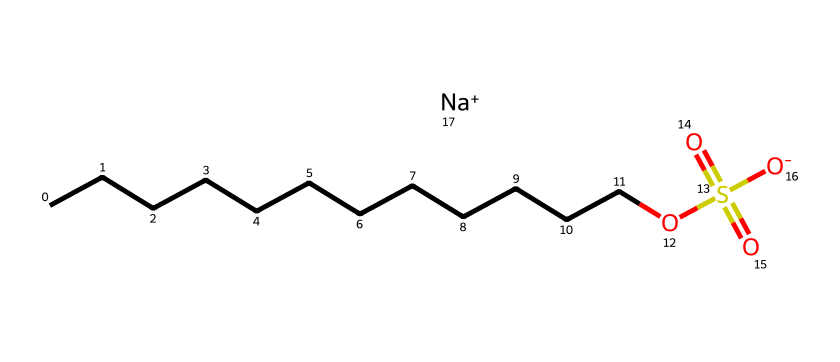What is the total number of carbon atoms in sodium dodecyl sulfate? The SMILES representation shows a straight chain of carbon atoms denoted by the "CCCCCCCCCCCC" part, which indicates there are 12 carbon atoms connected in a linear chain.
Answer: 12 How many oxygen atoms are in the structure of sodium dodecyl sulfate? In the SMILES, there are two oxygen atoms in the sulfate group "OS(=O)(=O)" and one additional oxygen in the hydroxyl part -O, resulting in a total of three oxygen atoms.
Answer: 3 What type of ion does sodium dodecyl sulfate contain? The "Na+" part of the SMILES indicates the presence of a sodium ion, which is a positively charged ion (cation) associated with the surfactant.
Answer: sodium ion What feature of sodium dodecyl sulfate contributes to its surfactant properties? The presence of a long hydrophobic carbon chain (the "CCCCCCCCCCCC" part) combined with a hydrophilic sulfate group contributes significantly to its surfactant properties, allowing it to reduce surface tension in water.
Answer: hydrophobic carbon chain and hydrophilic sulfate What functional group is present in sodium dodecyl sulfate? The "OS(=O)(=O)" part indicates that this molecule contains a sulfate functional group, which is key to its surfactant functionality.
Answer: sulfate What does the presence of the sodium ion imply about the solubility of sodium dodecyl sulfate in water? The presence of the sodium ion suggests that sodium dodecyl sulfate is ionic and hence soluble in water, as ionic compounds generally dissolve well due to their ability to interact with water molecules.
Answer: soluble in water How does the structure of sodium dodecyl sulfate affect its common usage in personal care products? The long hydrophobic tail makes it effective in reducing surface tension and allowing for the mixing of oil and water, while the hydrophilic head allows it to interact well with water, making it ideal for use in cleaning and personal care formulations.
Answer: effective in cleaning and foaming 